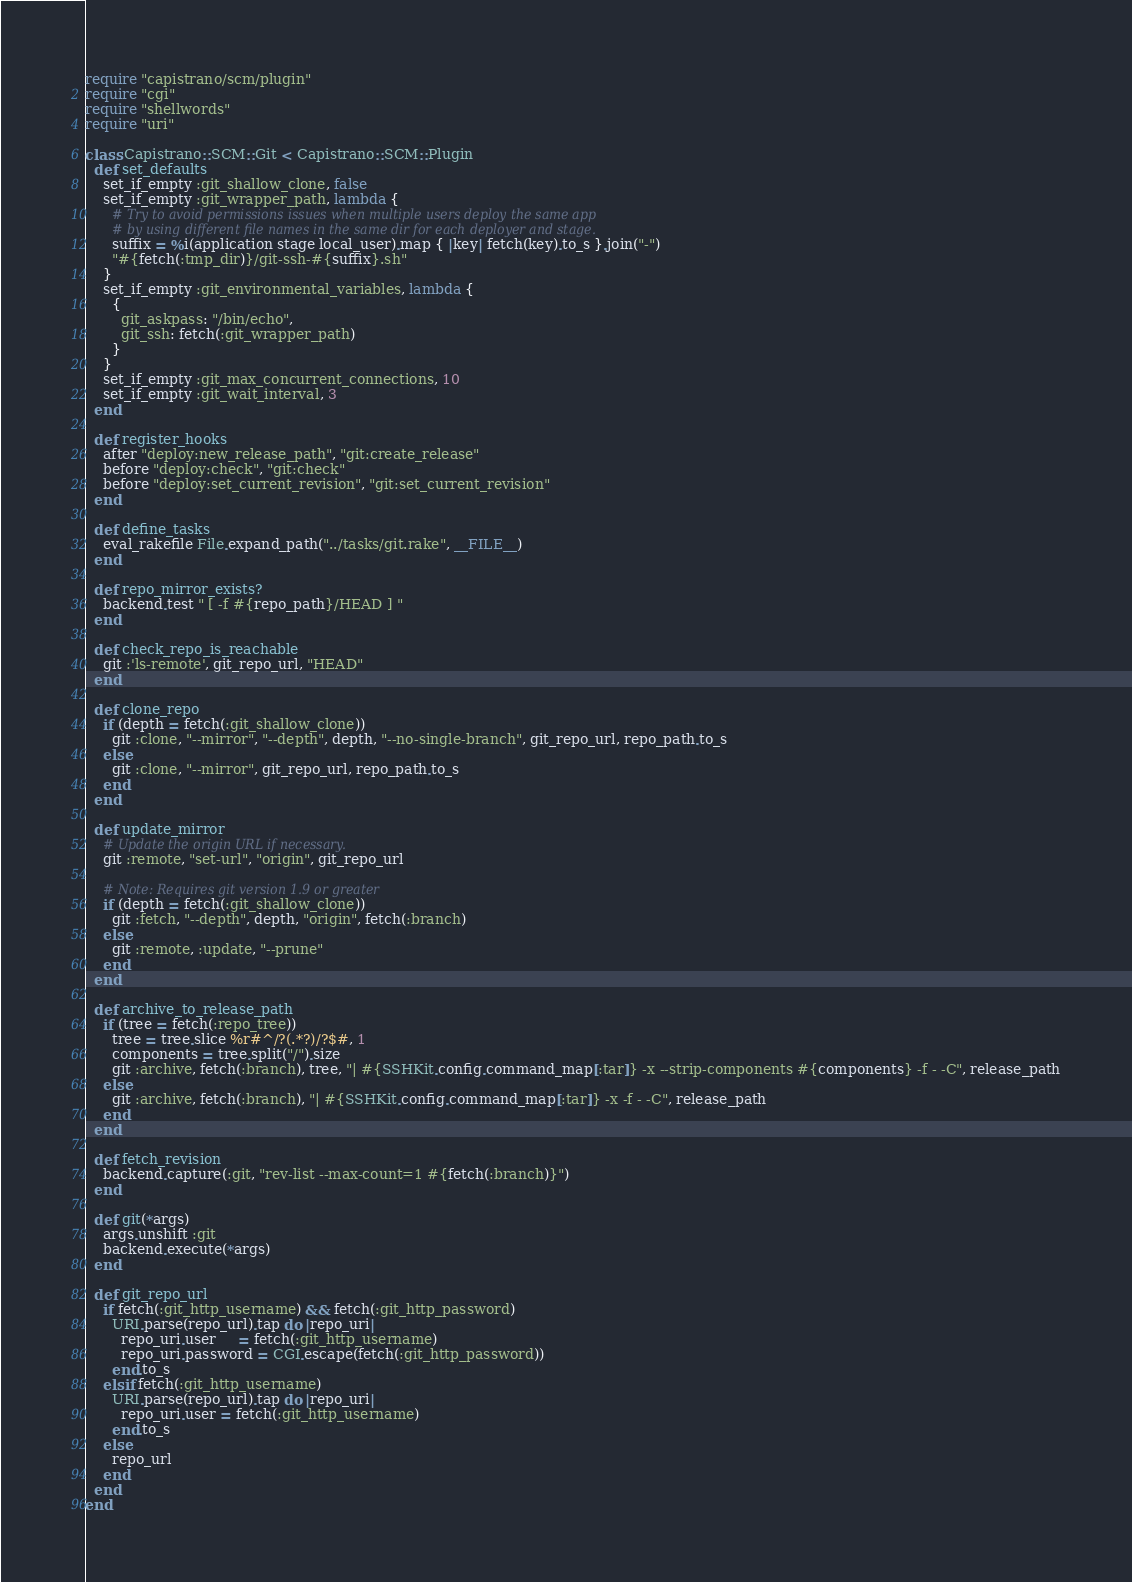<code> <loc_0><loc_0><loc_500><loc_500><_Ruby_>require "capistrano/scm/plugin"
require "cgi"
require "shellwords"
require "uri"

class Capistrano::SCM::Git < Capistrano::SCM::Plugin
  def set_defaults
    set_if_empty :git_shallow_clone, false
    set_if_empty :git_wrapper_path, lambda {
      # Try to avoid permissions issues when multiple users deploy the same app
      # by using different file names in the same dir for each deployer and stage.
      suffix = %i(application stage local_user).map { |key| fetch(key).to_s }.join("-")
      "#{fetch(:tmp_dir)}/git-ssh-#{suffix}.sh"
    }
    set_if_empty :git_environmental_variables, lambda {
      {
        git_askpass: "/bin/echo",
        git_ssh: fetch(:git_wrapper_path)
      }
    }
    set_if_empty :git_max_concurrent_connections, 10
    set_if_empty :git_wait_interval, 3
  end

  def register_hooks
    after "deploy:new_release_path", "git:create_release"
    before "deploy:check", "git:check"
    before "deploy:set_current_revision", "git:set_current_revision"
  end

  def define_tasks
    eval_rakefile File.expand_path("../tasks/git.rake", __FILE__)
  end

  def repo_mirror_exists?
    backend.test " [ -f #{repo_path}/HEAD ] "
  end

  def check_repo_is_reachable
    git :'ls-remote', git_repo_url, "HEAD"
  end

  def clone_repo
    if (depth = fetch(:git_shallow_clone))
      git :clone, "--mirror", "--depth", depth, "--no-single-branch", git_repo_url, repo_path.to_s
    else
      git :clone, "--mirror", git_repo_url, repo_path.to_s
    end
  end

  def update_mirror
    # Update the origin URL if necessary.
    git :remote, "set-url", "origin", git_repo_url

    # Note: Requires git version 1.9 or greater
    if (depth = fetch(:git_shallow_clone))
      git :fetch, "--depth", depth, "origin", fetch(:branch)
    else
      git :remote, :update, "--prune"
    end
  end

  def archive_to_release_path
    if (tree = fetch(:repo_tree))
      tree = tree.slice %r#^/?(.*?)/?$#, 1
      components = tree.split("/").size
      git :archive, fetch(:branch), tree, "| #{SSHKit.config.command_map[:tar]} -x --strip-components #{components} -f - -C", release_path
    else
      git :archive, fetch(:branch), "| #{SSHKit.config.command_map[:tar]} -x -f - -C", release_path
    end
  end

  def fetch_revision
    backend.capture(:git, "rev-list --max-count=1 #{fetch(:branch)}")
  end

  def git(*args)
    args.unshift :git
    backend.execute(*args)
  end

  def git_repo_url
    if fetch(:git_http_username) && fetch(:git_http_password)
      URI.parse(repo_url).tap do |repo_uri|
        repo_uri.user     = fetch(:git_http_username)
        repo_uri.password = CGI.escape(fetch(:git_http_password))
      end.to_s
    elsif fetch(:git_http_username)
      URI.parse(repo_url).tap do |repo_uri|
        repo_uri.user = fetch(:git_http_username)
      end.to_s
    else
      repo_url
    end
  end
end
</code> 